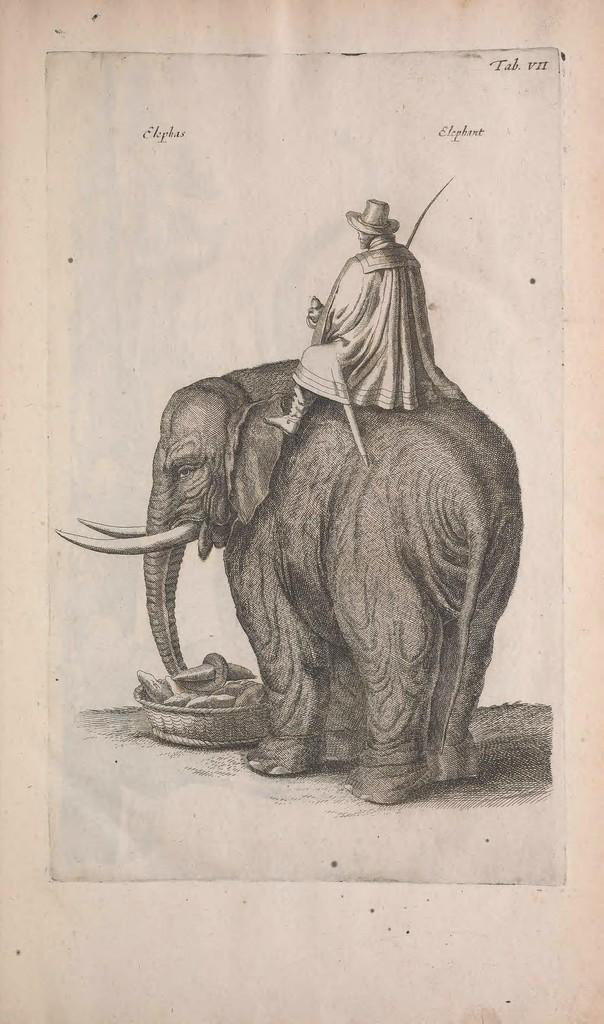What is depicted on the paper in the image? There is an elephant sketch, a basket sketch, and a person sketch on the paper in the image. Can you describe the content of the sketches? The paper contains sketches of an elephant, a basket, and a person. What type of salt is sprinkled on the person sketch in the image? There is no salt present in the image, as it features a paper with sketches of an elephant, a basket, and a person. 